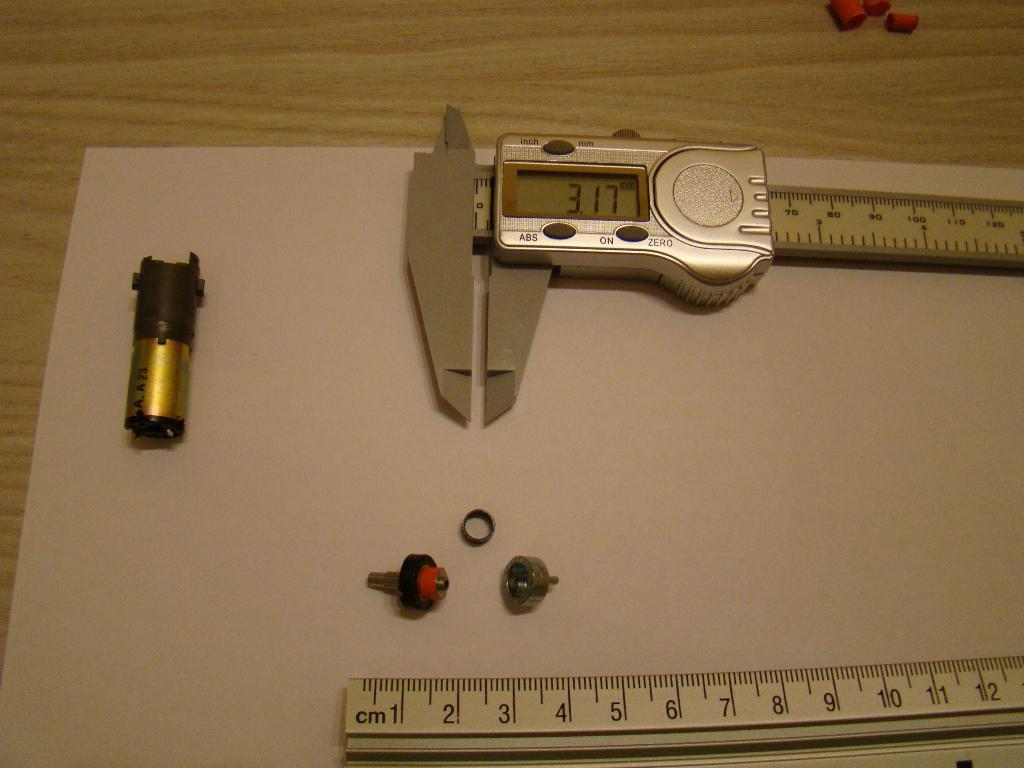<image>
Render a clear and concise summary of the photo. A digital ruler's screen display shows a measurement of 3.17 